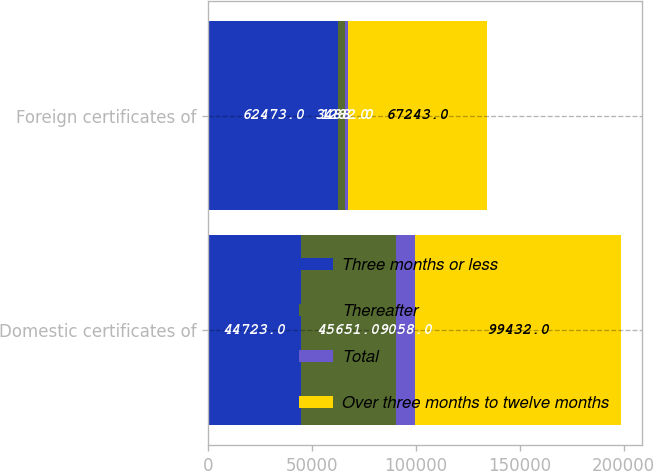<chart> <loc_0><loc_0><loc_500><loc_500><stacked_bar_chart><ecel><fcel>Domestic certificates of<fcel>Foreign certificates of<nl><fcel>Three months or less<fcel>44723<fcel>62473<nl><fcel>Thereafter<fcel>45651<fcel>3488<nl><fcel>Total<fcel>9058<fcel>1282<nl><fcel>Over three months to twelve months<fcel>99432<fcel>67243<nl></chart> 